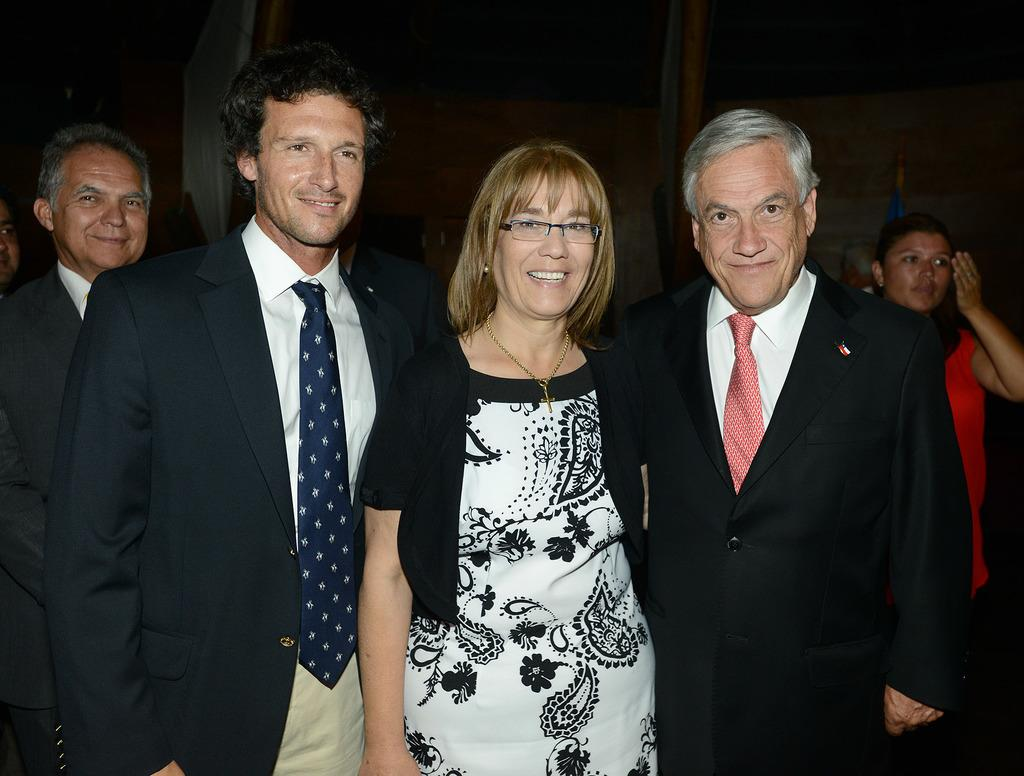How many people are in the image? There is a group of people in the image. What are the people doing in the image? The people are standing and smiling. What can be seen in the background of the image? There is a wall in the background of the image. What type of island can be seen in the background of the image? There is no island present in the image; it only features a wall in the background. 